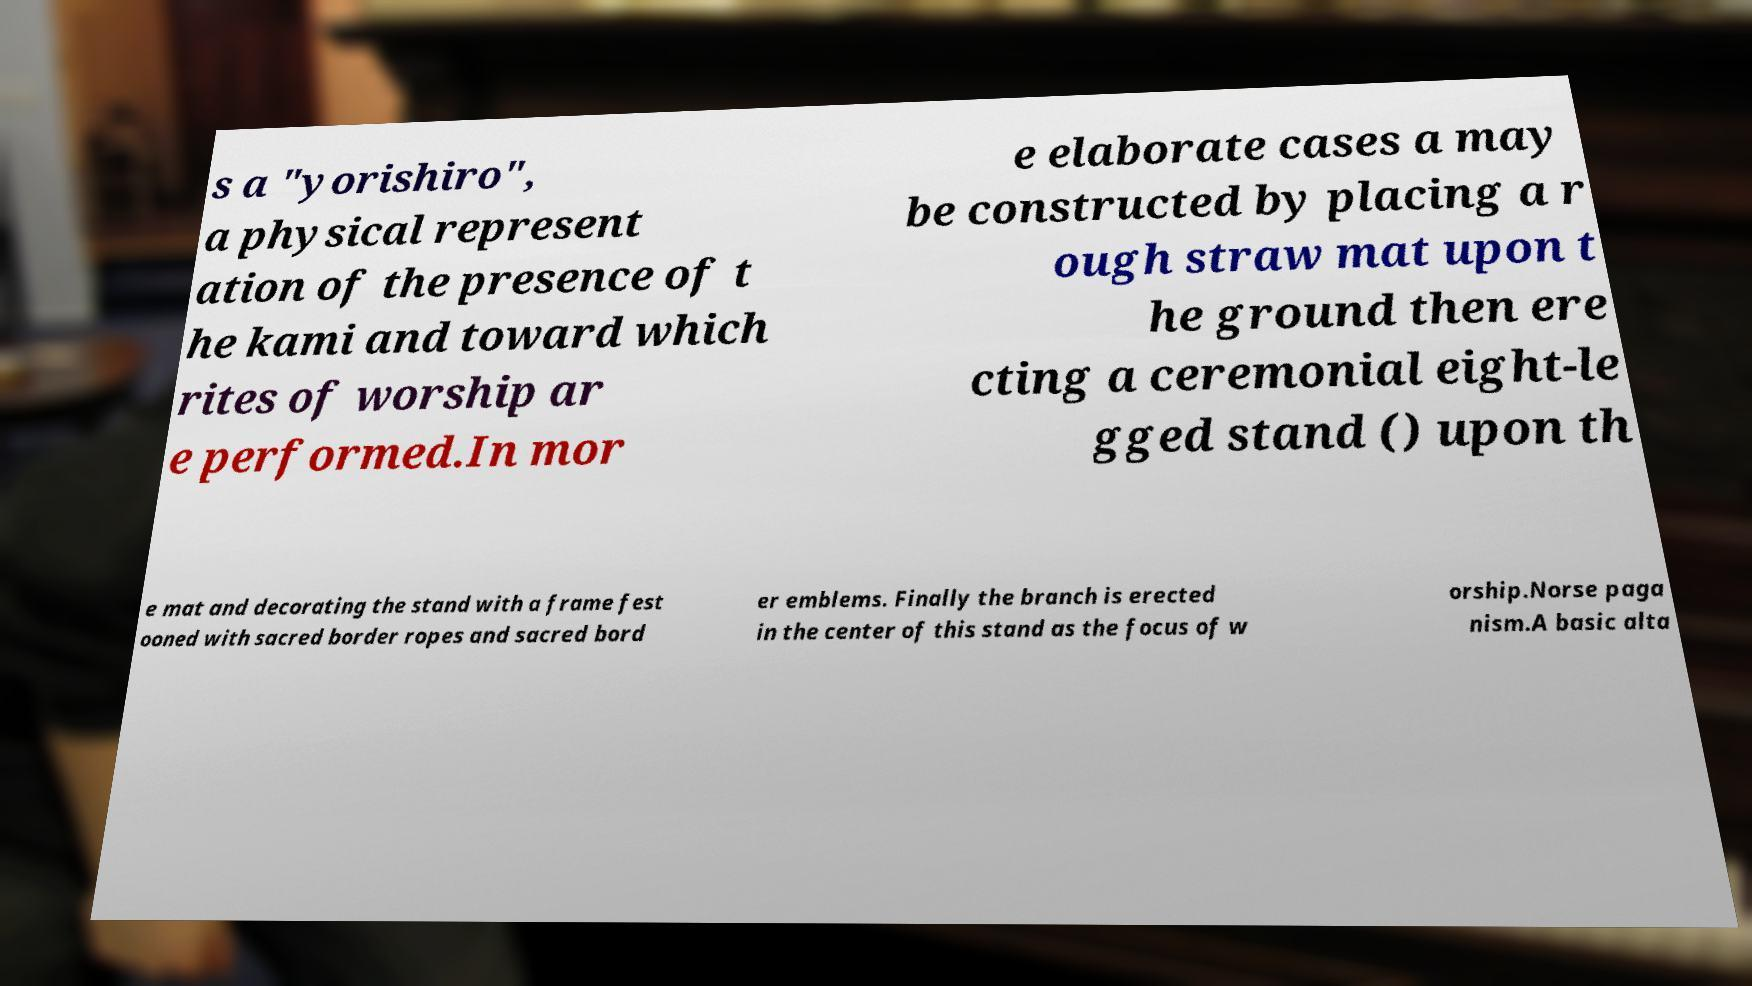There's text embedded in this image that I need extracted. Can you transcribe it verbatim? s a "yorishiro", a physical represent ation of the presence of t he kami and toward which rites of worship ar e performed.In mor e elaborate cases a may be constructed by placing a r ough straw mat upon t he ground then ere cting a ceremonial eight-le gged stand () upon th e mat and decorating the stand with a frame fest ooned with sacred border ropes and sacred bord er emblems. Finally the branch is erected in the center of this stand as the focus of w orship.Norse paga nism.A basic alta 